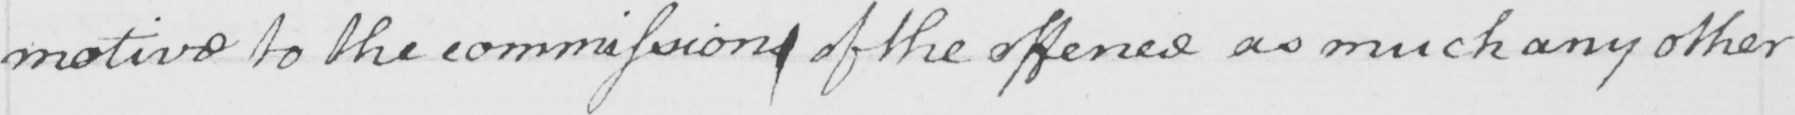What does this handwritten line say? motive to the commissions of the offence as much any other 